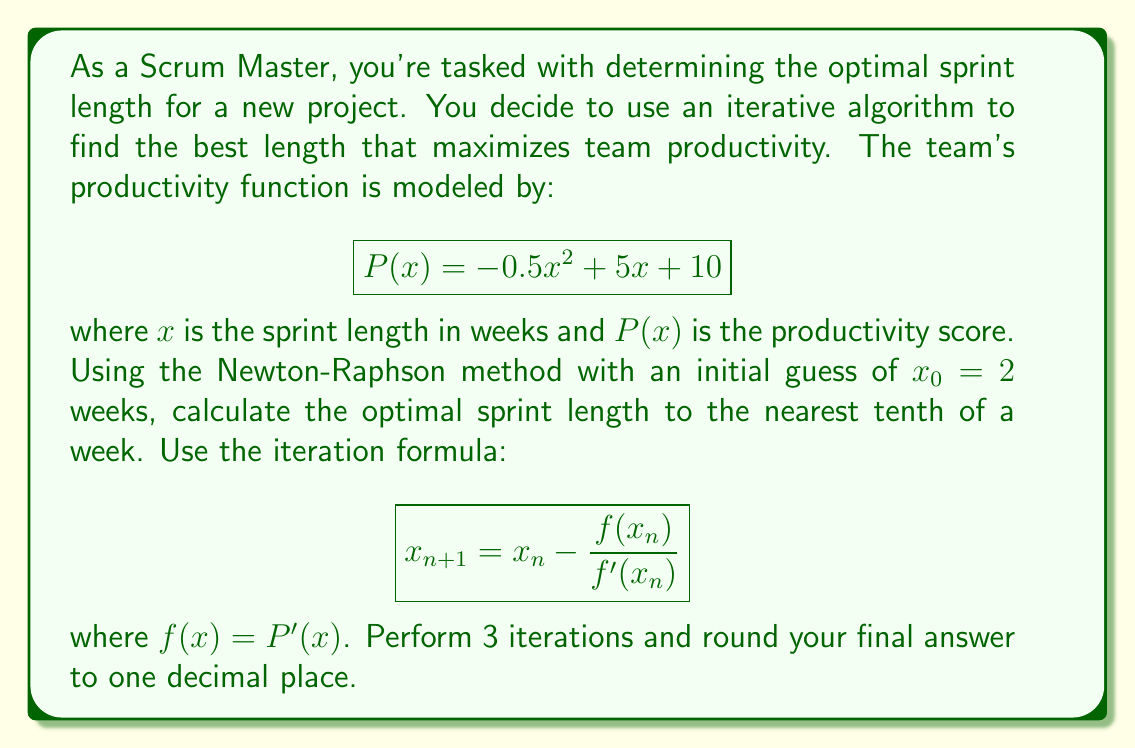Can you solve this math problem? To solve this problem, we'll follow these steps:

1) First, we need to find $f(x)$, which is the derivative of $P(x)$:
   $$P(x) = -0.5x^2 + 5x + 10$$
   $$f(x) = P'(x) = -x + 5$$

2) We also need $f'(x)$:
   $$f'(x) = -1$$

3) Now we can apply the Newton-Raphson method:
   $$x_{n+1} = x_n - \frac{f(x_n)}{f'(x_n)} = x_n - \frac{-x_n + 5}{-1} = x_n + (-x_n + 5) = 5$$

4) Let's perform 3 iterations:

   Iteration 1: $x_1 = 2 + (-2 + 5) = 5$
   
   Iteration 2: $x_2 = 5 + (-5 + 5) = 5$
   
   Iteration 3: $x_3 = 5 + (-5 + 5) = 5$

5) We can see that the method converges immediately to 5, which is the optimal sprint length.

6) To verify, we can check that this is indeed the maximum of $P(x)$:
   $$P'(x) = -x + 5$$
   Setting this to zero:
   $$-x + 5 = 0$$
   $$x = 5$$

   And the second derivative is negative ($P''(x) = -1$), confirming this is a maximum.

Therefore, the optimal sprint length is 5.0 weeks.
Answer: 5.0 weeks 